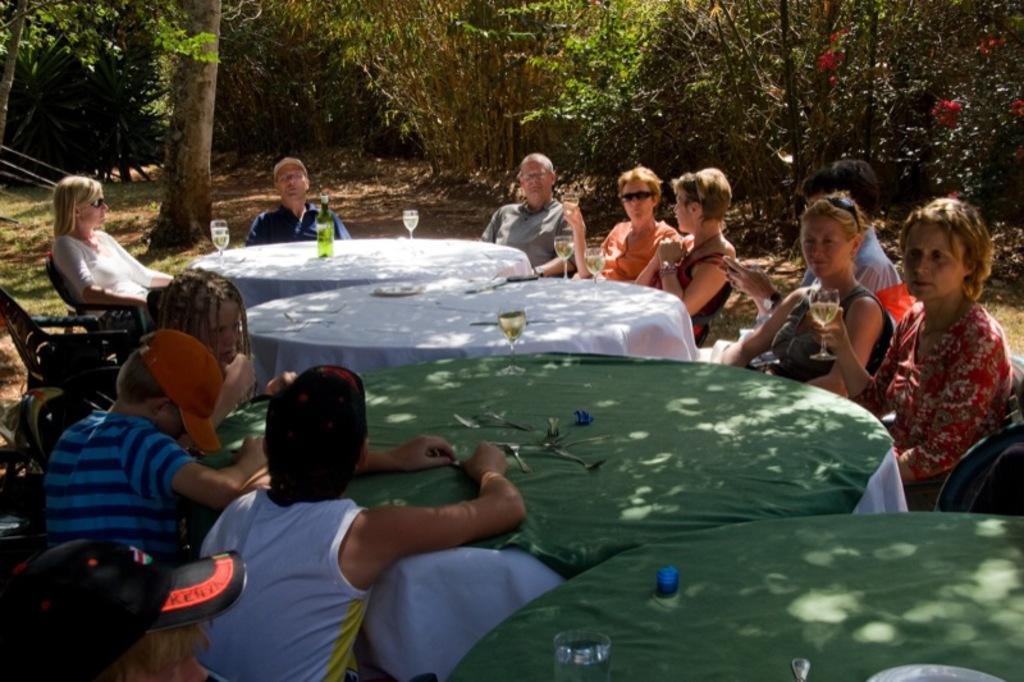How would you summarize this image in a sentence or two? This picture is clicked in a garden. In the center of the picture there are four tables covered with clothes, on the table there are spoons, glasses and bottle. On the right there are people seated in chair. On the left there are people seated in chairs. In the background there are trees. 